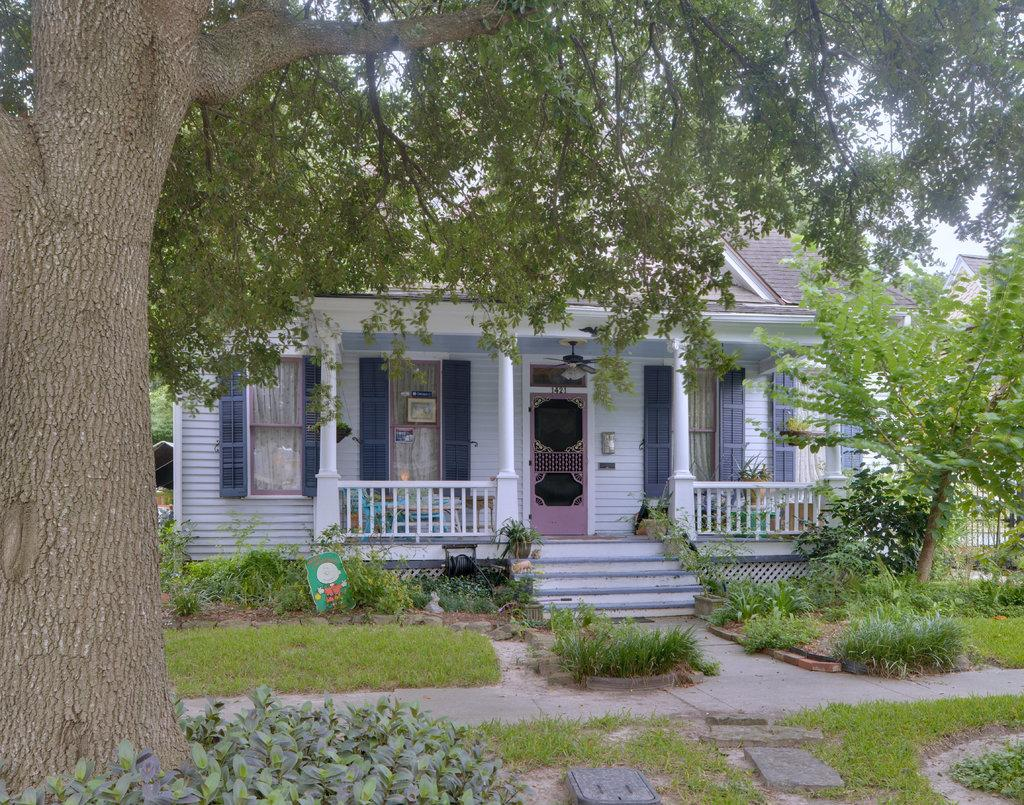What type of structure is visible in the image? There is a house in the image. What can be seen in front of the house? There are plants and trees in front of the house. What type of stick is being used for comfort in the image? There is no stick present in the image, and no indication of comfort being addressed. 